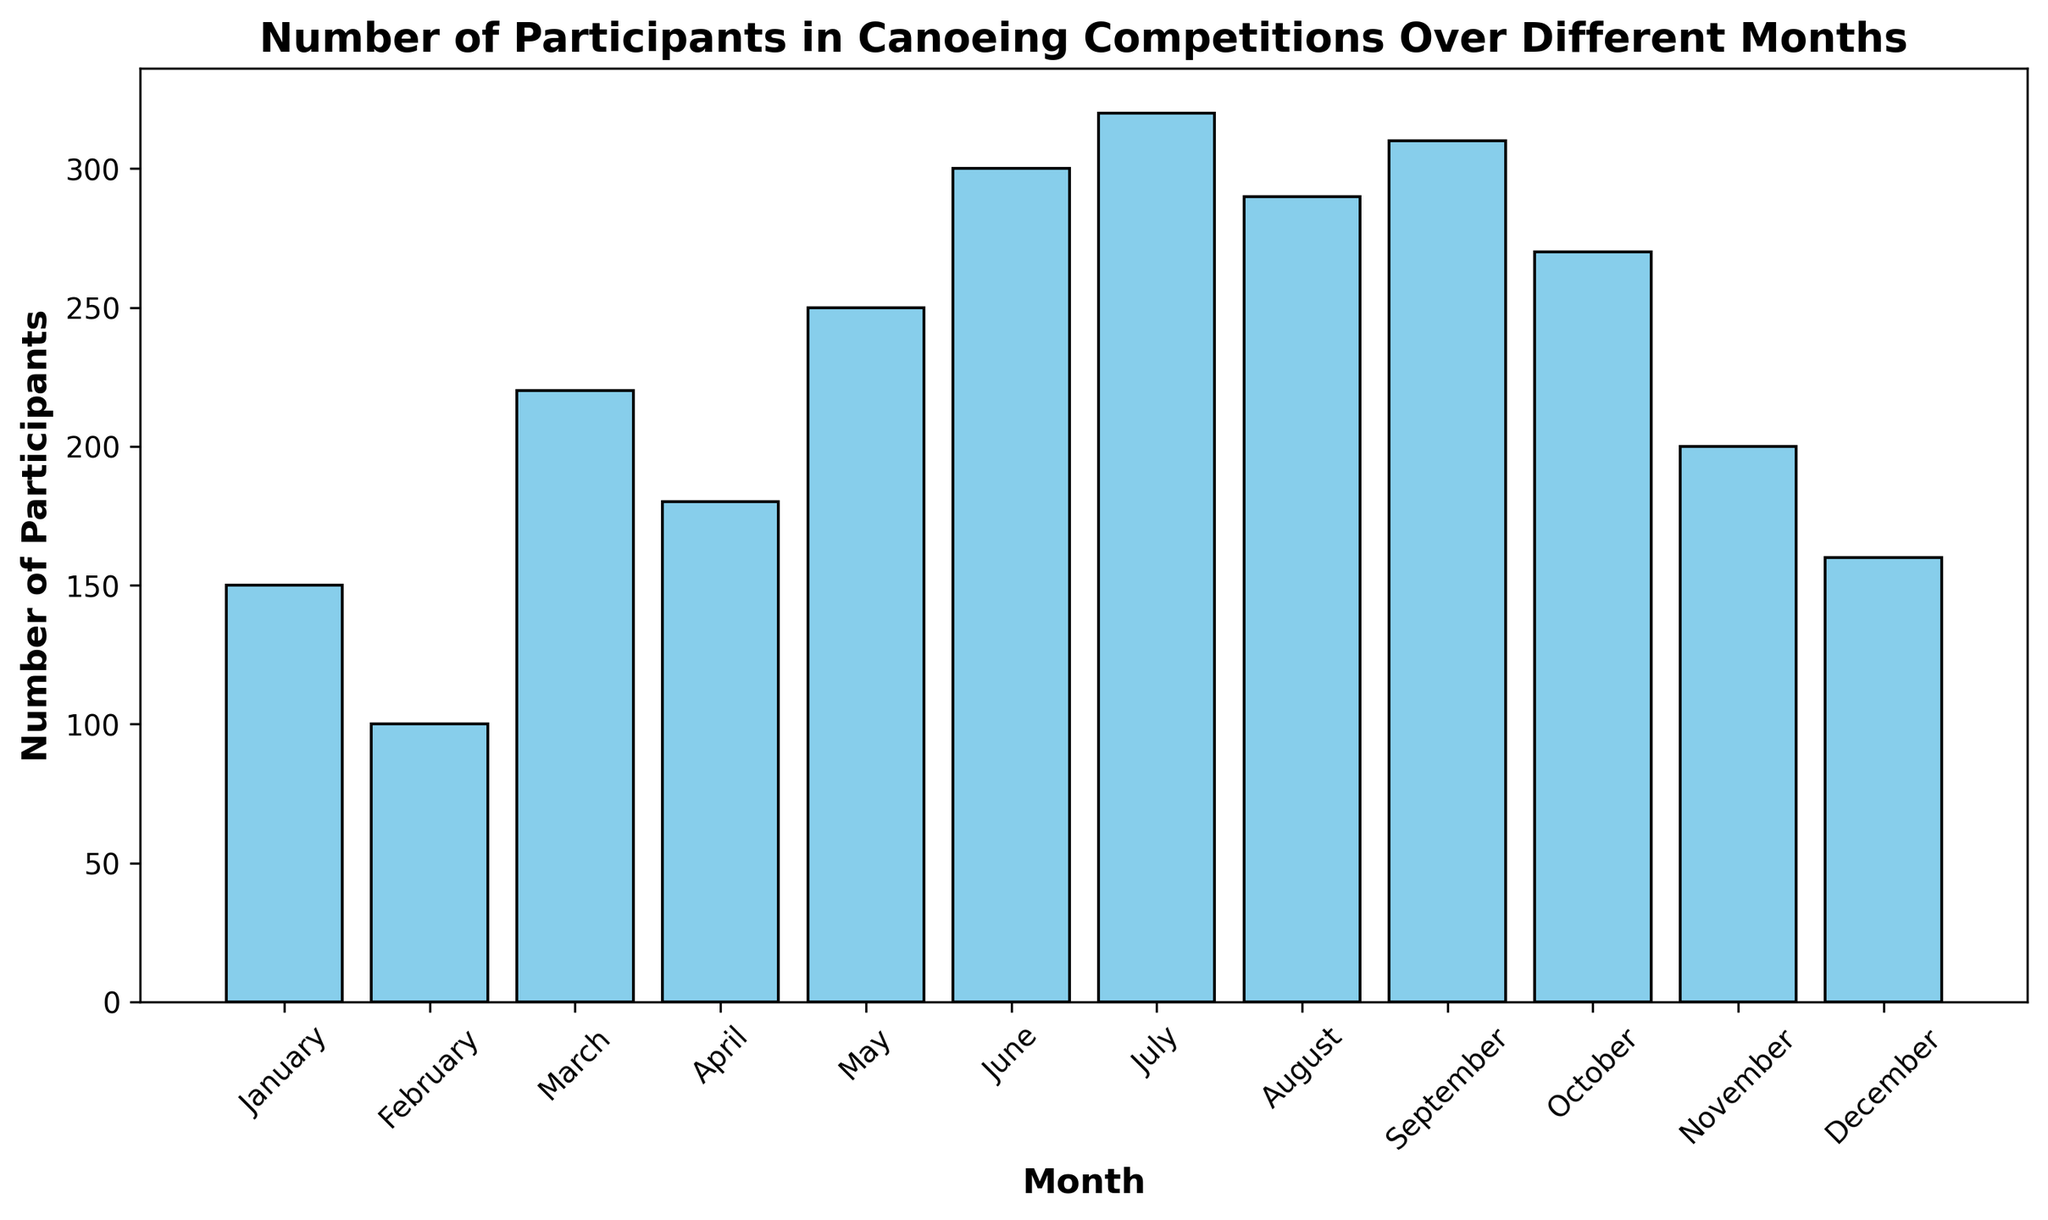Which month has the highest number of participants? By observing the height of the bars in the histogram, July has the highest bar.
Answer: July Which months have more than 250 participants? The months with bars higher than the 250 mark on the y-axis are June, July, August, and September.
Answer: June, July, August, September What is the difference in the number of participants between the month with the highest and the month with the lowest participants? The highest number of participants is in July (320), and the lowest is in February (100). So, the difference is 320 - 100.
Answer: 220 What is the average number of participants from January to June? Sum the participants from January to June: 150 + 100 + 220 + 180 + 250 + 300 = 1200. Divide by 6 (the number of months).
Answer: 200 Which month has a number of participants closest to the average number of participants across all months? Calculate the average: (150 + 100 + 220 + 180 + 250 + 300 + 320 + 290 + 310 + 270 + 200 + 160) / 12 = 220. The month with participants closest to 220 is March with 220 participants.
Answer: March In which season does the highest participation occur (considering summer: June-August)? Sum the participants from June to August: 300 + 320 + 290 = 910. Sum the other seasons if needed for comparison, but clearly, summer has the highest with 910 participants.
Answer: Summer Are there any months with exactly 200 participants? By looking at the bars, November has exactly 200 participants.
Answer: November 